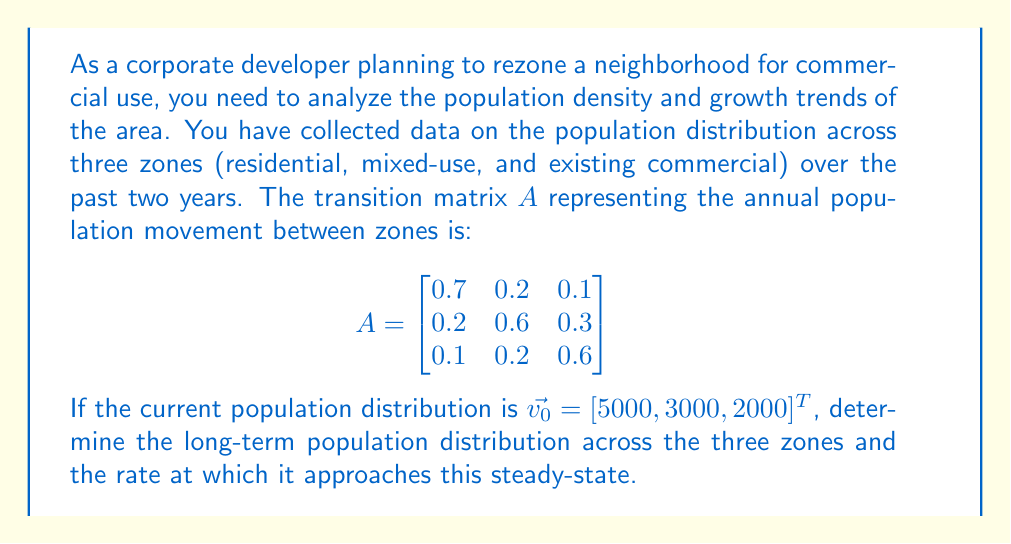Show me your answer to this math problem. To solve this problem, we need to find the eigenvectors and eigenvalues of the transition matrix $A$. The dominant eigenvector will give us the long-term population distribution, while the corresponding eigenvalue will indicate the rate of convergence.

1. Find the eigenvalues of $A$:
   Solve $\det(A - \lambda I) = 0$
   
   $$\det\begin{bmatrix}
   0.7-\lambda & 0.2 & 0.1 \\
   0.2 & 0.6-\lambda & 0.3 \\
   0.1 & 0.2 & 0.6-\lambda
   \end{bmatrix} = 0$$

   This yields the characteristic equation:
   $-\lambda^3 + 1.9\lambda^2 - 0.94\lambda + 0.14 = 0$

   Solving this equation gives us the eigenvalues:
   $\lambda_1 = 1$, $\lambda_2 \approx 0.5789$, $\lambda_3 \approx 0.3211$

2. Find the eigenvector corresponding to $\lambda_1 = 1$:
   Solve $(A - I)\vec{v} = \vec{0}$

   This gives us the eigenvector $\vec{v_1} = [10, 7, 5]^T$

3. Normalize the eigenvector to get the long-term population distribution:
   $$\vec{v_1} = \frac{1}{22}[10, 7, 5]^T \approx [0.4545, 0.3182, 0.2273]^T$$

4. The rate of convergence to the steady-state is determined by the second largest eigenvalue, $\lambda_2 \approx 0.5789$. The smaller this value, the faster the convergence.

5. To get the actual long-term population numbers, multiply the total population by the normalized eigenvector:
   Total population = 5000 + 3000 + 2000 = 10000
   Long-term distribution = $10000 \times [0.4545, 0.3182, 0.2273]^T$
Answer: The long-term population distribution across the three zones (residential, mixed-use, and existing commercial) is approximately [4545, 3182, 2273]. The rate of convergence to this steady-state is determined by $\lambda_2 \approx 0.5789$, indicating a relatively fast approach to the long-term distribution. 